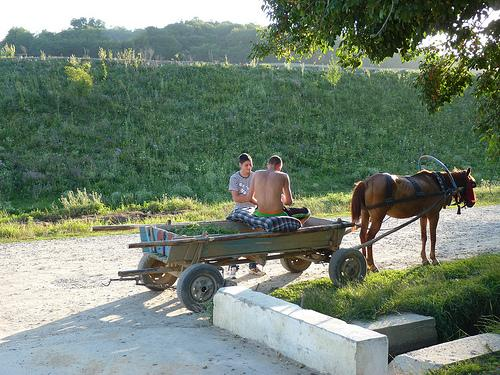What kind of cushion can be seen in the image and describe its pattern? A checkered cushion can be seen in the image with a black and white checkered pattern. Evaluate the overall sentiment of the image based on the interactions of the objects and people. The overall sentiment of the image is neutral, featuring interactions between people, animals, and objects in a casual setting. Count the number of black wheels in the image. There are 7 black wheels in the image. State the type of tree that the green leaves in the image are from. It is not possible to identify the exact type of tree from the green leaves alone. What is the primary interaction between the two young men in the image? The primary interaction between the two young men is that they are engaged in a conversation. Provide a detailed description of the wooden cart in the image. The wooden cart in the image has wheels and is being pulled by a brown horse, with a young man sitting inside it. Identify the color of the horse in the image and what it is attached to. The horse is brown and it is attached to a wooden cart with a young man in it. What type of terrain can be seen in the background of the image? A steep grassy hill can be seen in the background of the image. Explain the condition of the horse in the image based on its physical appearance. The horse appears to be malnourished as its ribs are sticking out. Describe the shorts worn by one of the individuals in the image. The shorts are black with a green stripe on them. Is there any text visible in the image? No Identify the object referred to as "a steap grassy hill". An image area with coordinates X:8, Y:41, Width:489, and Height:489 What does the horse do in the image? The horse is pulling a wooden cart. What is the nature of the cart in the image? Wooden with wheels Are there any unusual aspects in this image? The horse's ribs are sticking out, indicating it might be malnourished. What is the color of the horse's harness? Brown Is there an elephant hidden behind the wooden cart with wheels? No, it's not mentioned in the image. What color is the pillow present in the image? Black and white checkered What are the two people doing in the image? Talking How many wheels are on the wooden cart? At least 6 visible wheels are black. What is the color of the stripe on the shorts? Green Describe the interaction between the horse and the cart in the image. The brown horse is pulling a wooden cart with a young man in it. Assess the quality of the image. Good What are the people wearing in the image? One has black shorts with a green stripe. What type of material is the cart made from? Wood What is the wheel color? Black How many people are present in the image? Two young men What plant part is present in the image? Green leaves from a tree What do the two men appear to be doing in the image? They are talking. List all objects in the image with their coordinates. horse (X:347, Y:147), men (X:224, Y:147), cushion (X:234, Y:208), cart (X:97, Y:217), wheel (X:177, Y:283), wheel (X:185, Y:275), wheel (X:179, Y:266), wheel (X:182, Y:257), wheel (X:176, Y:269), wheel (X:180, Y:297), wheel (X:183, Y:285), cement block (X:180, Y:275), hill (X:8, Y:41), shorts (X:245, Y:202), leaves (X:252, Y:5) What is the sentiment of the image? Neutral 